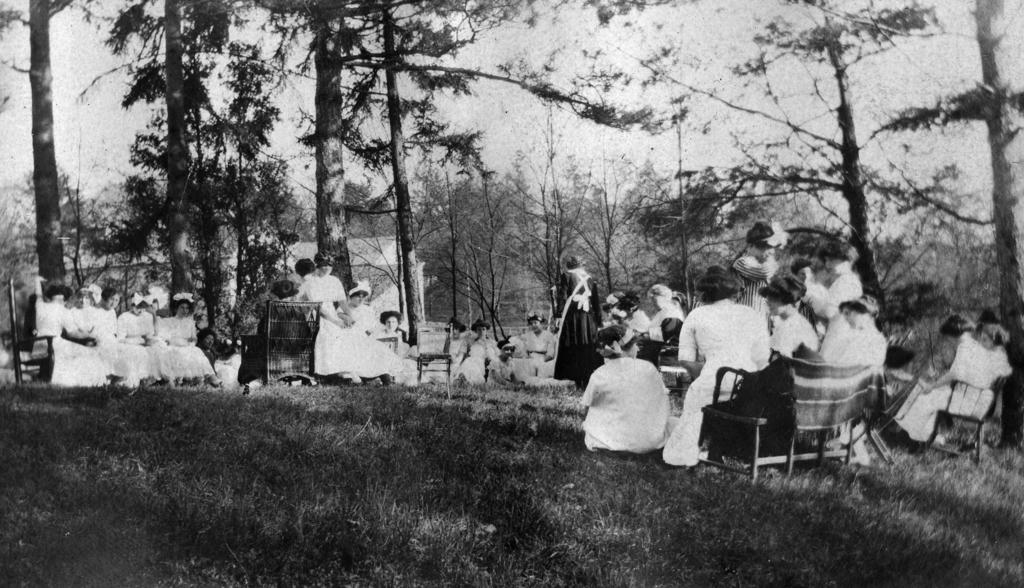What type of vegetation can be seen in the image? There are trees in the image. What else can be seen on the ground in the image? There is grass in the image. What are some of the people in the image doing? There are people sitting on benches and standing in the image. How is the image presented in terms of color? The image is in black and white. What type of science experiment is being conducted in the image? There is no science experiment present in the image; it features trees, grass, and people in a park-like setting. Can you see a hen in the image? There is no hen present in the image. 